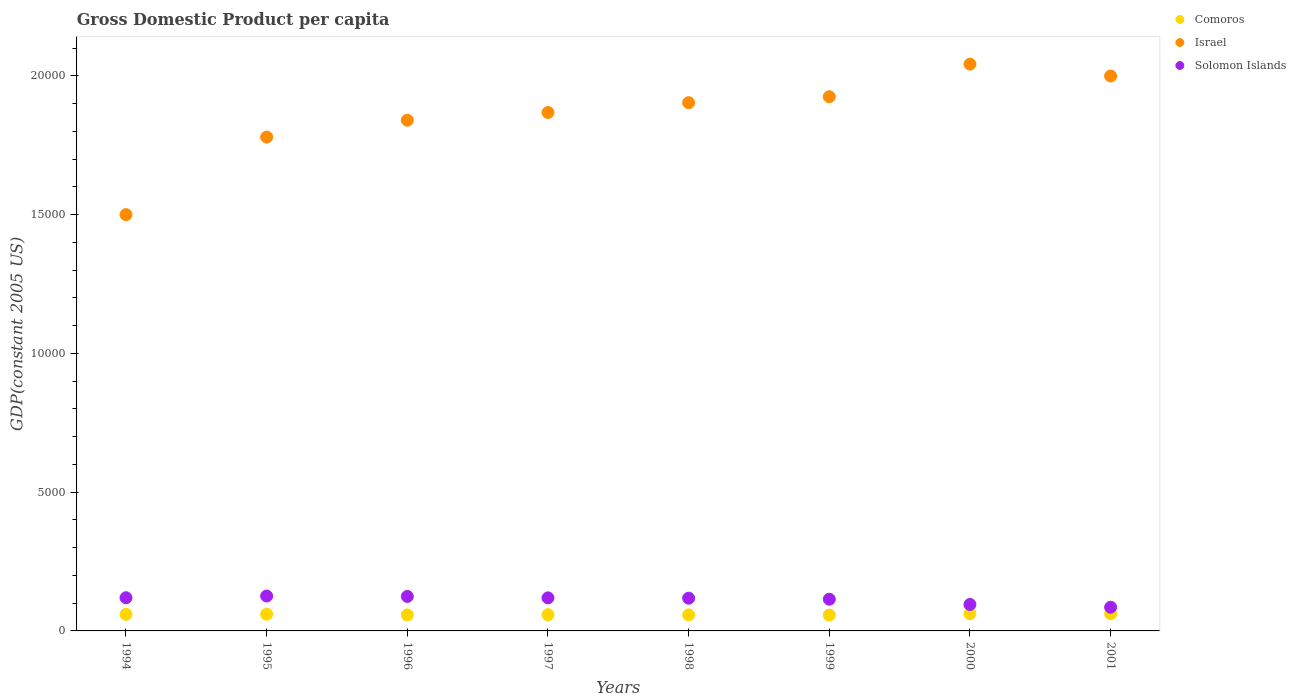How many different coloured dotlines are there?
Your answer should be compact. 3. Is the number of dotlines equal to the number of legend labels?
Ensure brevity in your answer.  Yes. What is the GDP per capita in Comoros in 1994?
Provide a short and direct response. 597.9. Across all years, what is the maximum GDP per capita in Solomon Islands?
Provide a short and direct response. 1257.72. Across all years, what is the minimum GDP per capita in Israel?
Keep it short and to the point. 1.50e+04. In which year was the GDP per capita in Israel maximum?
Give a very brief answer. 2000. What is the total GDP per capita in Israel in the graph?
Offer a very short reply. 1.49e+05. What is the difference between the GDP per capita in Comoros in 1995 and that in 2001?
Offer a very short reply. -16.24. What is the difference between the GDP per capita in Comoros in 1994 and the GDP per capita in Israel in 1999?
Provide a short and direct response. -1.87e+04. What is the average GDP per capita in Israel per year?
Your response must be concise. 1.86e+04. In the year 1999, what is the difference between the GDP per capita in Solomon Islands and GDP per capita in Comoros?
Your answer should be very brief. 568.47. In how many years, is the GDP per capita in Solomon Islands greater than 8000 US$?
Make the answer very short. 0. What is the ratio of the GDP per capita in Solomon Islands in 1994 to that in 1995?
Offer a terse response. 0.95. Is the GDP per capita in Solomon Islands in 1995 less than that in 1997?
Your answer should be very brief. No. What is the difference between the highest and the second highest GDP per capita in Solomon Islands?
Offer a terse response. 15.1. What is the difference between the highest and the lowest GDP per capita in Comoros?
Your answer should be very brief. 46.21. Is the sum of the GDP per capita in Comoros in 1999 and 2000 greater than the maximum GDP per capita in Israel across all years?
Your answer should be very brief. No. Is it the case that in every year, the sum of the GDP per capita in Comoros and GDP per capita in Israel  is greater than the GDP per capita in Solomon Islands?
Ensure brevity in your answer.  Yes. Does the GDP per capita in Israel monotonically increase over the years?
Give a very brief answer. No. Is the GDP per capita in Israel strictly less than the GDP per capita in Solomon Islands over the years?
Provide a succinct answer. No. What is the difference between two consecutive major ticks on the Y-axis?
Provide a short and direct response. 5000. Are the values on the major ticks of Y-axis written in scientific E-notation?
Ensure brevity in your answer.  No. Does the graph contain grids?
Offer a terse response. No. What is the title of the graph?
Make the answer very short. Gross Domestic Product per capita. What is the label or title of the X-axis?
Your response must be concise. Years. What is the label or title of the Y-axis?
Provide a succinct answer. GDP(constant 2005 US). What is the GDP(constant 2005 US) in Comoros in 1994?
Your response must be concise. 597.9. What is the GDP(constant 2005 US) of Israel in 1994?
Your answer should be compact. 1.50e+04. What is the GDP(constant 2005 US) in Solomon Islands in 1994?
Keep it short and to the point. 1195.38. What is the GDP(constant 2005 US) in Comoros in 1995?
Give a very brief answer. 602.35. What is the GDP(constant 2005 US) in Israel in 1995?
Provide a short and direct response. 1.78e+04. What is the GDP(constant 2005 US) of Solomon Islands in 1995?
Offer a very short reply. 1257.72. What is the GDP(constant 2005 US) of Comoros in 1996?
Your answer should be very brief. 578.41. What is the GDP(constant 2005 US) of Israel in 1996?
Keep it short and to the point. 1.84e+04. What is the GDP(constant 2005 US) of Solomon Islands in 1996?
Ensure brevity in your answer.  1242.62. What is the GDP(constant 2005 US) in Comoros in 1997?
Offer a very short reply. 585.63. What is the GDP(constant 2005 US) of Israel in 1997?
Your response must be concise. 1.87e+04. What is the GDP(constant 2005 US) in Solomon Islands in 1997?
Offer a terse response. 1191.13. What is the GDP(constant 2005 US) in Comoros in 1998?
Provide a short and direct response. 577.57. What is the GDP(constant 2005 US) in Israel in 1998?
Offer a very short reply. 1.90e+04. What is the GDP(constant 2005 US) in Solomon Islands in 1998?
Your response must be concise. 1179.38. What is the GDP(constant 2005 US) of Comoros in 1999?
Offer a very short reply. 573.54. What is the GDP(constant 2005 US) in Israel in 1999?
Give a very brief answer. 1.92e+04. What is the GDP(constant 2005 US) of Solomon Islands in 1999?
Your answer should be compact. 1142.01. What is the GDP(constant 2005 US) in Comoros in 2000?
Offer a terse response. 619.76. What is the GDP(constant 2005 US) of Israel in 2000?
Your response must be concise. 2.04e+04. What is the GDP(constant 2005 US) in Solomon Islands in 2000?
Ensure brevity in your answer.  952.92. What is the GDP(constant 2005 US) of Comoros in 2001?
Provide a succinct answer. 618.6. What is the GDP(constant 2005 US) in Israel in 2001?
Make the answer very short. 2.00e+04. What is the GDP(constant 2005 US) in Solomon Islands in 2001?
Your response must be concise. 853.7. Across all years, what is the maximum GDP(constant 2005 US) of Comoros?
Your response must be concise. 619.76. Across all years, what is the maximum GDP(constant 2005 US) of Israel?
Your response must be concise. 2.04e+04. Across all years, what is the maximum GDP(constant 2005 US) of Solomon Islands?
Offer a terse response. 1257.72. Across all years, what is the minimum GDP(constant 2005 US) in Comoros?
Provide a short and direct response. 573.54. Across all years, what is the minimum GDP(constant 2005 US) in Israel?
Provide a succinct answer. 1.50e+04. Across all years, what is the minimum GDP(constant 2005 US) in Solomon Islands?
Your answer should be very brief. 853.7. What is the total GDP(constant 2005 US) of Comoros in the graph?
Make the answer very short. 4753.75. What is the total GDP(constant 2005 US) of Israel in the graph?
Your response must be concise. 1.49e+05. What is the total GDP(constant 2005 US) in Solomon Islands in the graph?
Your answer should be compact. 9014.86. What is the difference between the GDP(constant 2005 US) in Comoros in 1994 and that in 1995?
Your answer should be very brief. -4.45. What is the difference between the GDP(constant 2005 US) in Israel in 1994 and that in 1995?
Ensure brevity in your answer.  -2793.13. What is the difference between the GDP(constant 2005 US) of Solomon Islands in 1994 and that in 1995?
Make the answer very short. -62.34. What is the difference between the GDP(constant 2005 US) of Comoros in 1994 and that in 1996?
Offer a terse response. 19.5. What is the difference between the GDP(constant 2005 US) in Israel in 1994 and that in 1996?
Your answer should be compact. -3400.92. What is the difference between the GDP(constant 2005 US) of Solomon Islands in 1994 and that in 1996?
Your answer should be very brief. -47.24. What is the difference between the GDP(constant 2005 US) in Comoros in 1994 and that in 1997?
Keep it short and to the point. 12.28. What is the difference between the GDP(constant 2005 US) in Israel in 1994 and that in 1997?
Ensure brevity in your answer.  -3679.51. What is the difference between the GDP(constant 2005 US) in Solomon Islands in 1994 and that in 1997?
Make the answer very short. 4.25. What is the difference between the GDP(constant 2005 US) of Comoros in 1994 and that in 1998?
Offer a very short reply. 20.34. What is the difference between the GDP(constant 2005 US) in Israel in 1994 and that in 1998?
Offer a terse response. -4033.44. What is the difference between the GDP(constant 2005 US) in Solomon Islands in 1994 and that in 1998?
Your answer should be compact. 16. What is the difference between the GDP(constant 2005 US) of Comoros in 1994 and that in 1999?
Ensure brevity in your answer.  24.36. What is the difference between the GDP(constant 2005 US) in Israel in 1994 and that in 1999?
Provide a succinct answer. -4248.29. What is the difference between the GDP(constant 2005 US) of Solomon Islands in 1994 and that in 1999?
Provide a short and direct response. 53.37. What is the difference between the GDP(constant 2005 US) of Comoros in 1994 and that in 2000?
Make the answer very short. -21.85. What is the difference between the GDP(constant 2005 US) in Israel in 1994 and that in 2000?
Provide a succinct answer. -5422.64. What is the difference between the GDP(constant 2005 US) of Solomon Islands in 1994 and that in 2000?
Make the answer very short. 242.46. What is the difference between the GDP(constant 2005 US) of Comoros in 1994 and that in 2001?
Ensure brevity in your answer.  -20.69. What is the difference between the GDP(constant 2005 US) of Israel in 1994 and that in 2001?
Provide a short and direct response. -4995.07. What is the difference between the GDP(constant 2005 US) in Solomon Islands in 1994 and that in 2001?
Keep it short and to the point. 341.68. What is the difference between the GDP(constant 2005 US) of Comoros in 1995 and that in 1996?
Your response must be concise. 23.95. What is the difference between the GDP(constant 2005 US) in Israel in 1995 and that in 1996?
Provide a succinct answer. -607.79. What is the difference between the GDP(constant 2005 US) of Solomon Islands in 1995 and that in 1996?
Keep it short and to the point. 15.1. What is the difference between the GDP(constant 2005 US) of Comoros in 1995 and that in 1997?
Make the answer very short. 16.73. What is the difference between the GDP(constant 2005 US) of Israel in 1995 and that in 1997?
Offer a very short reply. -886.38. What is the difference between the GDP(constant 2005 US) in Solomon Islands in 1995 and that in 1997?
Offer a very short reply. 66.59. What is the difference between the GDP(constant 2005 US) of Comoros in 1995 and that in 1998?
Offer a terse response. 24.79. What is the difference between the GDP(constant 2005 US) of Israel in 1995 and that in 1998?
Offer a very short reply. -1240.3. What is the difference between the GDP(constant 2005 US) in Solomon Islands in 1995 and that in 1998?
Offer a terse response. 78.34. What is the difference between the GDP(constant 2005 US) in Comoros in 1995 and that in 1999?
Your answer should be very brief. 28.81. What is the difference between the GDP(constant 2005 US) in Israel in 1995 and that in 1999?
Keep it short and to the point. -1455.16. What is the difference between the GDP(constant 2005 US) in Solomon Islands in 1995 and that in 1999?
Your answer should be compact. 115.71. What is the difference between the GDP(constant 2005 US) of Comoros in 1995 and that in 2000?
Provide a short and direct response. -17.4. What is the difference between the GDP(constant 2005 US) in Israel in 1995 and that in 2000?
Your response must be concise. -2629.51. What is the difference between the GDP(constant 2005 US) in Solomon Islands in 1995 and that in 2000?
Your answer should be compact. 304.81. What is the difference between the GDP(constant 2005 US) of Comoros in 1995 and that in 2001?
Your response must be concise. -16.24. What is the difference between the GDP(constant 2005 US) in Israel in 1995 and that in 2001?
Your response must be concise. -2201.94. What is the difference between the GDP(constant 2005 US) of Solomon Islands in 1995 and that in 2001?
Your answer should be compact. 404.02. What is the difference between the GDP(constant 2005 US) in Comoros in 1996 and that in 1997?
Your response must be concise. -7.22. What is the difference between the GDP(constant 2005 US) of Israel in 1996 and that in 1997?
Your answer should be compact. -278.59. What is the difference between the GDP(constant 2005 US) in Solomon Islands in 1996 and that in 1997?
Provide a succinct answer. 51.49. What is the difference between the GDP(constant 2005 US) of Comoros in 1996 and that in 1998?
Your response must be concise. 0.84. What is the difference between the GDP(constant 2005 US) of Israel in 1996 and that in 1998?
Your answer should be very brief. -632.51. What is the difference between the GDP(constant 2005 US) in Solomon Islands in 1996 and that in 1998?
Give a very brief answer. 63.24. What is the difference between the GDP(constant 2005 US) in Comoros in 1996 and that in 1999?
Your answer should be compact. 4.86. What is the difference between the GDP(constant 2005 US) of Israel in 1996 and that in 1999?
Your response must be concise. -847.37. What is the difference between the GDP(constant 2005 US) in Solomon Islands in 1996 and that in 1999?
Your answer should be very brief. 100.61. What is the difference between the GDP(constant 2005 US) of Comoros in 1996 and that in 2000?
Ensure brevity in your answer.  -41.35. What is the difference between the GDP(constant 2005 US) in Israel in 1996 and that in 2000?
Give a very brief answer. -2021.72. What is the difference between the GDP(constant 2005 US) in Solomon Islands in 1996 and that in 2000?
Your answer should be compact. 289.7. What is the difference between the GDP(constant 2005 US) of Comoros in 1996 and that in 2001?
Make the answer very short. -40.19. What is the difference between the GDP(constant 2005 US) in Israel in 1996 and that in 2001?
Provide a succinct answer. -1594.15. What is the difference between the GDP(constant 2005 US) in Solomon Islands in 1996 and that in 2001?
Offer a terse response. 388.92. What is the difference between the GDP(constant 2005 US) of Comoros in 1997 and that in 1998?
Provide a succinct answer. 8.06. What is the difference between the GDP(constant 2005 US) in Israel in 1997 and that in 1998?
Provide a succinct answer. -353.93. What is the difference between the GDP(constant 2005 US) of Solomon Islands in 1997 and that in 1998?
Your response must be concise. 11.76. What is the difference between the GDP(constant 2005 US) in Comoros in 1997 and that in 1999?
Make the answer very short. 12.08. What is the difference between the GDP(constant 2005 US) of Israel in 1997 and that in 1999?
Make the answer very short. -568.78. What is the difference between the GDP(constant 2005 US) in Solomon Islands in 1997 and that in 1999?
Provide a short and direct response. 49.12. What is the difference between the GDP(constant 2005 US) of Comoros in 1997 and that in 2000?
Ensure brevity in your answer.  -34.13. What is the difference between the GDP(constant 2005 US) in Israel in 1997 and that in 2000?
Keep it short and to the point. -1743.13. What is the difference between the GDP(constant 2005 US) in Solomon Islands in 1997 and that in 2000?
Keep it short and to the point. 238.22. What is the difference between the GDP(constant 2005 US) in Comoros in 1997 and that in 2001?
Ensure brevity in your answer.  -32.97. What is the difference between the GDP(constant 2005 US) in Israel in 1997 and that in 2001?
Your answer should be compact. -1315.56. What is the difference between the GDP(constant 2005 US) in Solomon Islands in 1997 and that in 2001?
Provide a succinct answer. 337.43. What is the difference between the GDP(constant 2005 US) of Comoros in 1998 and that in 1999?
Provide a short and direct response. 4.02. What is the difference between the GDP(constant 2005 US) of Israel in 1998 and that in 1999?
Keep it short and to the point. -214.85. What is the difference between the GDP(constant 2005 US) of Solomon Islands in 1998 and that in 1999?
Give a very brief answer. 37.36. What is the difference between the GDP(constant 2005 US) of Comoros in 1998 and that in 2000?
Ensure brevity in your answer.  -42.19. What is the difference between the GDP(constant 2005 US) in Israel in 1998 and that in 2000?
Make the answer very short. -1389.2. What is the difference between the GDP(constant 2005 US) in Solomon Islands in 1998 and that in 2000?
Your answer should be compact. 226.46. What is the difference between the GDP(constant 2005 US) of Comoros in 1998 and that in 2001?
Offer a very short reply. -41.03. What is the difference between the GDP(constant 2005 US) of Israel in 1998 and that in 2001?
Offer a terse response. -961.64. What is the difference between the GDP(constant 2005 US) of Solomon Islands in 1998 and that in 2001?
Ensure brevity in your answer.  325.68. What is the difference between the GDP(constant 2005 US) in Comoros in 1999 and that in 2000?
Ensure brevity in your answer.  -46.21. What is the difference between the GDP(constant 2005 US) of Israel in 1999 and that in 2000?
Offer a very short reply. -1174.35. What is the difference between the GDP(constant 2005 US) in Solomon Islands in 1999 and that in 2000?
Offer a terse response. 189.1. What is the difference between the GDP(constant 2005 US) of Comoros in 1999 and that in 2001?
Ensure brevity in your answer.  -45.05. What is the difference between the GDP(constant 2005 US) of Israel in 1999 and that in 2001?
Offer a terse response. -746.78. What is the difference between the GDP(constant 2005 US) of Solomon Islands in 1999 and that in 2001?
Offer a very short reply. 288.31. What is the difference between the GDP(constant 2005 US) in Comoros in 2000 and that in 2001?
Keep it short and to the point. 1.16. What is the difference between the GDP(constant 2005 US) of Israel in 2000 and that in 2001?
Provide a short and direct response. 427.56. What is the difference between the GDP(constant 2005 US) in Solomon Islands in 2000 and that in 2001?
Offer a terse response. 99.22. What is the difference between the GDP(constant 2005 US) of Comoros in 1994 and the GDP(constant 2005 US) of Israel in 1995?
Your answer should be very brief. -1.72e+04. What is the difference between the GDP(constant 2005 US) in Comoros in 1994 and the GDP(constant 2005 US) in Solomon Islands in 1995?
Give a very brief answer. -659.82. What is the difference between the GDP(constant 2005 US) in Israel in 1994 and the GDP(constant 2005 US) in Solomon Islands in 1995?
Offer a very short reply. 1.37e+04. What is the difference between the GDP(constant 2005 US) of Comoros in 1994 and the GDP(constant 2005 US) of Israel in 1996?
Give a very brief answer. -1.78e+04. What is the difference between the GDP(constant 2005 US) of Comoros in 1994 and the GDP(constant 2005 US) of Solomon Islands in 1996?
Give a very brief answer. -644.72. What is the difference between the GDP(constant 2005 US) of Israel in 1994 and the GDP(constant 2005 US) of Solomon Islands in 1996?
Your answer should be very brief. 1.38e+04. What is the difference between the GDP(constant 2005 US) of Comoros in 1994 and the GDP(constant 2005 US) of Israel in 1997?
Your answer should be compact. -1.81e+04. What is the difference between the GDP(constant 2005 US) of Comoros in 1994 and the GDP(constant 2005 US) of Solomon Islands in 1997?
Offer a very short reply. -593.23. What is the difference between the GDP(constant 2005 US) in Israel in 1994 and the GDP(constant 2005 US) in Solomon Islands in 1997?
Keep it short and to the point. 1.38e+04. What is the difference between the GDP(constant 2005 US) of Comoros in 1994 and the GDP(constant 2005 US) of Israel in 1998?
Provide a short and direct response. -1.84e+04. What is the difference between the GDP(constant 2005 US) in Comoros in 1994 and the GDP(constant 2005 US) in Solomon Islands in 1998?
Offer a very short reply. -581.47. What is the difference between the GDP(constant 2005 US) in Israel in 1994 and the GDP(constant 2005 US) in Solomon Islands in 1998?
Ensure brevity in your answer.  1.38e+04. What is the difference between the GDP(constant 2005 US) in Comoros in 1994 and the GDP(constant 2005 US) in Israel in 1999?
Ensure brevity in your answer.  -1.87e+04. What is the difference between the GDP(constant 2005 US) of Comoros in 1994 and the GDP(constant 2005 US) of Solomon Islands in 1999?
Offer a terse response. -544.11. What is the difference between the GDP(constant 2005 US) of Israel in 1994 and the GDP(constant 2005 US) of Solomon Islands in 1999?
Your answer should be compact. 1.39e+04. What is the difference between the GDP(constant 2005 US) of Comoros in 1994 and the GDP(constant 2005 US) of Israel in 2000?
Your response must be concise. -1.98e+04. What is the difference between the GDP(constant 2005 US) of Comoros in 1994 and the GDP(constant 2005 US) of Solomon Islands in 2000?
Provide a short and direct response. -355.01. What is the difference between the GDP(constant 2005 US) in Israel in 1994 and the GDP(constant 2005 US) in Solomon Islands in 2000?
Offer a very short reply. 1.40e+04. What is the difference between the GDP(constant 2005 US) of Comoros in 1994 and the GDP(constant 2005 US) of Israel in 2001?
Keep it short and to the point. -1.94e+04. What is the difference between the GDP(constant 2005 US) in Comoros in 1994 and the GDP(constant 2005 US) in Solomon Islands in 2001?
Provide a short and direct response. -255.8. What is the difference between the GDP(constant 2005 US) in Israel in 1994 and the GDP(constant 2005 US) in Solomon Islands in 2001?
Your answer should be compact. 1.41e+04. What is the difference between the GDP(constant 2005 US) in Comoros in 1995 and the GDP(constant 2005 US) in Israel in 1996?
Offer a very short reply. -1.78e+04. What is the difference between the GDP(constant 2005 US) in Comoros in 1995 and the GDP(constant 2005 US) in Solomon Islands in 1996?
Give a very brief answer. -640.27. What is the difference between the GDP(constant 2005 US) of Israel in 1995 and the GDP(constant 2005 US) of Solomon Islands in 1996?
Keep it short and to the point. 1.66e+04. What is the difference between the GDP(constant 2005 US) in Comoros in 1995 and the GDP(constant 2005 US) in Israel in 1997?
Your answer should be compact. -1.81e+04. What is the difference between the GDP(constant 2005 US) in Comoros in 1995 and the GDP(constant 2005 US) in Solomon Islands in 1997?
Make the answer very short. -588.78. What is the difference between the GDP(constant 2005 US) in Israel in 1995 and the GDP(constant 2005 US) in Solomon Islands in 1997?
Give a very brief answer. 1.66e+04. What is the difference between the GDP(constant 2005 US) in Comoros in 1995 and the GDP(constant 2005 US) in Israel in 1998?
Offer a terse response. -1.84e+04. What is the difference between the GDP(constant 2005 US) in Comoros in 1995 and the GDP(constant 2005 US) in Solomon Islands in 1998?
Make the answer very short. -577.02. What is the difference between the GDP(constant 2005 US) of Israel in 1995 and the GDP(constant 2005 US) of Solomon Islands in 1998?
Provide a short and direct response. 1.66e+04. What is the difference between the GDP(constant 2005 US) of Comoros in 1995 and the GDP(constant 2005 US) of Israel in 1999?
Offer a very short reply. -1.86e+04. What is the difference between the GDP(constant 2005 US) in Comoros in 1995 and the GDP(constant 2005 US) in Solomon Islands in 1999?
Offer a terse response. -539.66. What is the difference between the GDP(constant 2005 US) in Israel in 1995 and the GDP(constant 2005 US) in Solomon Islands in 1999?
Offer a very short reply. 1.67e+04. What is the difference between the GDP(constant 2005 US) in Comoros in 1995 and the GDP(constant 2005 US) in Israel in 2000?
Provide a short and direct response. -1.98e+04. What is the difference between the GDP(constant 2005 US) in Comoros in 1995 and the GDP(constant 2005 US) in Solomon Islands in 2000?
Offer a terse response. -350.56. What is the difference between the GDP(constant 2005 US) in Israel in 1995 and the GDP(constant 2005 US) in Solomon Islands in 2000?
Give a very brief answer. 1.68e+04. What is the difference between the GDP(constant 2005 US) of Comoros in 1995 and the GDP(constant 2005 US) of Israel in 2001?
Provide a succinct answer. -1.94e+04. What is the difference between the GDP(constant 2005 US) of Comoros in 1995 and the GDP(constant 2005 US) of Solomon Islands in 2001?
Make the answer very short. -251.35. What is the difference between the GDP(constant 2005 US) of Israel in 1995 and the GDP(constant 2005 US) of Solomon Islands in 2001?
Offer a terse response. 1.69e+04. What is the difference between the GDP(constant 2005 US) of Comoros in 1996 and the GDP(constant 2005 US) of Israel in 1997?
Give a very brief answer. -1.81e+04. What is the difference between the GDP(constant 2005 US) in Comoros in 1996 and the GDP(constant 2005 US) in Solomon Islands in 1997?
Offer a very short reply. -612.73. What is the difference between the GDP(constant 2005 US) of Israel in 1996 and the GDP(constant 2005 US) of Solomon Islands in 1997?
Your answer should be compact. 1.72e+04. What is the difference between the GDP(constant 2005 US) in Comoros in 1996 and the GDP(constant 2005 US) in Israel in 1998?
Your answer should be compact. -1.85e+04. What is the difference between the GDP(constant 2005 US) in Comoros in 1996 and the GDP(constant 2005 US) in Solomon Islands in 1998?
Your response must be concise. -600.97. What is the difference between the GDP(constant 2005 US) of Israel in 1996 and the GDP(constant 2005 US) of Solomon Islands in 1998?
Keep it short and to the point. 1.72e+04. What is the difference between the GDP(constant 2005 US) in Comoros in 1996 and the GDP(constant 2005 US) in Israel in 1999?
Give a very brief answer. -1.87e+04. What is the difference between the GDP(constant 2005 US) in Comoros in 1996 and the GDP(constant 2005 US) in Solomon Islands in 1999?
Ensure brevity in your answer.  -563.61. What is the difference between the GDP(constant 2005 US) of Israel in 1996 and the GDP(constant 2005 US) of Solomon Islands in 1999?
Ensure brevity in your answer.  1.73e+04. What is the difference between the GDP(constant 2005 US) in Comoros in 1996 and the GDP(constant 2005 US) in Israel in 2000?
Your response must be concise. -1.98e+04. What is the difference between the GDP(constant 2005 US) in Comoros in 1996 and the GDP(constant 2005 US) in Solomon Islands in 2000?
Give a very brief answer. -374.51. What is the difference between the GDP(constant 2005 US) in Israel in 1996 and the GDP(constant 2005 US) in Solomon Islands in 2000?
Give a very brief answer. 1.74e+04. What is the difference between the GDP(constant 2005 US) of Comoros in 1996 and the GDP(constant 2005 US) of Israel in 2001?
Ensure brevity in your answer.  -1.94e+04. What is the difference between the GDP(constant 2005 US) in Comoros in 1996 and the GDP(constant 2005 US) in Solomon Islands in 2001?
Offer a very short reply. -275.29. What is the difference between the GDP(constant 2005 US) of Israel in 1996 and the GDP(constant 2005 US) of Solomon Islands in 2001?
Provide a short and direct response. 1.75e+04. What is the difference between the GDP(constant 2005 US) in Comoros in 1997 and the GDP(constant 2005 US) in Israel in 1998?
Provide a succinct answer. -1.84e+04. What is the difference between the GDP(constant 2005 US) of Comoros in 1997 and the GDP(constant 2005 US) of Solomon Islands in 1998?
Provide a succinct answer. -593.75. What is the difference between the GDP(constant 2005 US) of Israel in 1997 and the GDP(constant 2005 US) of Solomon Islands in 1998?
Keep it short and to the point. 1.75e+04. What is the difference between the GDP(constant 2005 US) of Comoros in 1997 and the GDP(constant 2005 US) of Israel in 1999?
Keep it short and to the point. -1.87e+04. What is the difference between the GDP(constant 2005 US) in Comoros in 1997 and the GDP(constant 2005 US) in Solomon Islands in 1999?
Your answer should be compact. -556.39. What is the difference between the GDP(constant 2005 US) in Israel in 1997 and the GDP(constant 2005 US) in Solomon Islands in 1999?
Ensure brevity in your answer.  1.75e+04. What is the difference between the GDP(constant 2005 US) of Comoros in 1997 and the GDP(constant 2005 US) of Israel in 2000?
Ensure brevity in your answer.  -1.98e+04. What is the difference between the GDP(constant 2005 US) of Comoros in 1997 and the GDP(constant 2005 US) of Solomon Islands in 2000?
Your answer should be compact. -367.29. What is the difference between the GDP(constant 2005 US) of Israel in 1997 and the GDP(constant 2005 US) of Solomon Islands in 2000?
Offer a terse response. 1.77e+04. What is the difference between the GDP(constant 2005 US) of Comoros in 1997 and the GDP(constant 2005 US) of Israel in 2001?
Provide a succinct answer. -1.94e+04. What is the difference between the GDP(constant 2005 US) in Comoros in 1997 and the GDP(constant 2005 US) in Solomon Islands in 2001?
Your response must be concise. -268.07. What is the difference between the GDP(constant 2005 US) in Israel in 1997 and the GDP(constant 2005 US) in Solomon Islands in 2001?
Keep it short and to the point. 1.78e+04. What is the difference between the GDP(constant 2005 US) in Comoros in 1998 and the GDP(constant 2005 US) in Israel in 1999?
Offer a terse response. -1.87e+04. What is the difference between the GDP(constant 2005 US) of Comoros in 1998 and the GDP(constant 2005 US) of Solomon Islands in 1999?
Your answer should be very brief. -564.44. What is the difference between the GDP(constant 2005 US) of Israel in 1998 and the GDP(constant 2005 US) of Solomon Islands in 1999?
Provide a succinct answer. 1.79e+04. What is the difference between the GDP(constant 2005 US) of Comoros in 1998 and the GDP(constant 2005 US) of Israel in 2000?
Offer a very short reply. -1.98e+04. What is the difference between the GDP(constant 2005 US) in Comoros in 1998 and the GDP(constant 2005 US) in Solomon Islands in 2000?
Ensure brevity in your answer.  -375.35. What is the difference between the GDP(constant 2005 US) in Israel in 1998 and the GDP(constant 2005 US) in Solomon Islands in 2000?
Keep it short and to the point. 1.81e+04. What is the difference between the GDP(constant 2005 US) in Comoros in 1998 and the GDP(constant 2005 US) in Israel in 2001?
Ensure brevity in your answer.  -1.94e+04. What is the difference between the GDP(constant 2005 US) of Comoros in 1998 and the GDP(constant 2005 US) of Solomon Islands in 2001?
Your response must be concise. -276.13. What is the difference between the GDP(constant 2005 US) of Israel in 1998 and the GDP(constant 2005 US) of Solomon Islands in 2001?
Ensure brevity in your answer.  1.82e+04. What is the difference between the GDP(constant 2005 US) in Comoros in 1999 and the GDP(constant 2005 US) in Israel in 2000?
Provide a succinct answer. -1.98e+04. What is the difference between the GDP(constant 2005 US) of Comoros in 1999 and the GDP(constant 2005 US) of Solomon Islands in 2000?
Give a very brief answer. -379.37. What is the difference between the GDP(constant 2005 US) of Israel in 1999 and the GDP(constant 2005 US) of Solomon Islands in 2000?
Keep it short and to the point. 1.83e+04. What is the difference between the GDP(constant 2005 US) in Comoros in 1999 and the GDP(constant 2005 US) in Israel in 2001?
Make the answer very short. -1.94e+04. What is the difference between the GDP(constant 2005 US) of Comoros in 1999 and the GDP(constant 2005 US) of Solomon Islands in 2001?
Your answer should be very brief. -280.16. What is the difference between the GDP(constant 2005 US) of Israel in 1999 and the GDP(constant 2005 US) of Solomon Islands in 2001?
Make the answer very short. 1.84e+04. What is the difference between the GDP(constant 2005 US) of Comoros in 2000 and the GDP(constant 2005 US) of Israel in 2001?
Your answer should be compact. -1.94e+04. What is the difference between the GDP(constant 2005 US) in Comoros in 2000 and the GDP(constant 2005 US) in Solomon Islands in 2001?
Give a very brief answer. -233.94. What is the difference between the GDP(constant 2005 US) in Israel in 2000 and the GDP(constant 2005 US) in Solomon Islands in 2001?
Give a very brief answer. 1.96e+04. What is the average GDP(constant 2005 US) of Comoros per year?
Ensure brevity in your answer.  594.22. What is the average GDP(constant 2005 US) of Israel per year?
Your answer should be compact. 1.86e+04. What is the average GDP(constant 2005 US) in Solomon Islands per year?
Your answer should be compact. 1126.86. In the year 1994, what is the difference between the GDP(constant 2005 US) of Comoros and GDP(constant 2005 US) of Israel?
Offer a very short reply. -1.44e+04. In the year 1994, what is the difference between the GDP(constant 2005 US) of Comoros and GDP(constant 2005 US) of Solomon Islands?
Your response must be concise. -597.48. In the year 1994, what is the difference between the GDP(constant 2005 US) of Israel and GDP(constant 2005 US) of Solomon Islands?
Offer a terse response. 1.38e+04. In the year 1995, what is the difference between the GDP(constant 2005 US) of Comoros and GDP(constant 2005 US) of Israel?
Your response must be concise. -1.72e+04. In the year 1995, what is the difference between the GDP(constant 2005 US) in Comoros and GDP(constant 2005 US) in Solomon Islands?
Provide a succinct answer. -655.37. In the year 1995, what is the difference between the GDP(constant 2005 US) in Israel and GDP(constant 2005 US) in Solomon Islands?
Your answer should be compact. 1.65e+04. In the year 1996, what is the difference between the GDP(constant 2005 US) in Comoros and GDP(constant 2005 US) in Israel?
Your response must be concise. -1.78e+04. In the year 1996, what is the difference between the GDP(constant 2005 US) of Comoros and GDP(constant 2005 US) of Solomon Islands?
Ensure brevity in your answer.  -664.21. In the year 1996, what is the difference between the GDP(constant 2005 US) of Israel and GDP(constant 2005 US) of Solomon Islands?
Offer a very short reply. 1.72e+04. In the year 1997, what is the difference between the GDP(constant 2005 US) in Comoros and GDP(constant 2005 US) in Israel?
Provide a succinct answer. -1.81e+04. In the year 1997, what is the difference between the GDP(constant 2005 US) in Comoros and GDP(constant 2005 US) in Solomon Islands?
Provide a succinct answer. -605.51. In the year 1997, what is the difference between the GDP(constant 2005 US) of Israel and GDP(constant 2005 US) of Solomon Islands?
Offer a terse response. 1.75e+04. In the year 1998, what is the difference between the GDP(constant 2005 US) in Comoros and GDP(constant 2005 US) in Israel?
Offer a terse response. -1.85e+04. In the year 1998, what is the difference between the GDP(constant 2005 US) of Comoros and GDP(constant 2005 US) of Solomon Islands?
Your response must be concise. -601.81. In the year 1998, what is the difference between the GDP(constant 2005 US) in Israel and GDP(constant 2005 US) in Solomon Islands?
Provide a short and direct response. 1.79e+04. In the year 1999, what is the difference between the GDP(constant 2005 US) in Comoros and GDP(constant 2005 US) in Israel?
Your response must be concise. -1.87e+04. In the year 1999, what is the difference between the GDP(constant 2005 US) in Comoros and GDP(constant 2005 US) in Solomon Islands?
Give a very brief answer. -568.47. In the year 1999, what is the difference between the GDP(constant 2005 US) of Israel and GDP(constant 2005 US) of Solomon Islands?
Make the answer very short. 1.81e+04. In the year 2000, what is the difference between the GDP(constant 2005 US) of Comoros and GDP(constant 2005 US) of Israel?
Provide a short and direct response. -1.98e+04. In the year 2000, what is the difference between the GDP(constant 2005 US) of Comoros and GDP(constant 2005 US) of Solomon Islands?
Provide a succinct answer. -333.16. In the year 2000, what is the difference between the GDP(constant 2005 US) of Israel and GDP(constant 2005 US) of Solomon Islands?
Offer a very short reply. 1.95e+04. In the year 2001, what is the difference between the GDP(constant 2005 US) in Comoros and GDP(constant 2005 US) in Israel?
Give a very brief answer. -1.94e+04. In the year 2001, what is the difference between the GDP(constant 2005 US) of Comoros and GDP(constant 2005 US) of Solomon Islands?
Make the answer very short. -235.1. In the year 2001, what is the difference between the GDP(constant 2005 US) in Israel and GDP(constant 2005 US) in Solomon Islands?
Your response must be concise. 1.91e+04. What is the ratio of the GDP(constant 2005 US) in Comoros in 1994 to that in 1995?
Offer a terse response. 0.99. What is the ratio of the GDP(constant 2005 US) in Israel in 1994 to that in 1995?
Your answer should be very brief. 0.84. What is the ratio of the GDP(constant 2005 US) of Solomon Islands in 1994 to that in 1995?
Give a very brief answer. 0.95. What is the ratio of the GDP(constant 2005 US) of Comoros in 1994 to that in 1996?
Provide a short and direct response. 1.03. What is the ratio of the GDP(constant 2005 US) in Israel in 1994 to that in 1996?
Give a very brief answer. 0.82. What is the ratio of the GDP(constant 2005 US) of Comoros in 1994 to that in 1997?
Make the answer very short. 1.02. What is the ratio of the GDP(constant 2005 US) in Israel in 1994 to that in 1997?
Your answer should be compact. 0.8. What is the ratio of the GDP(constant 2005 US) of Solomon Islands in 1994 to that in 1997?
Make the answer very short. 1. What is the ratio of the GDP(constant 2005 US) of Comoros in 1994 to that in 1998?
Offer a very short reply. 1.04. What is the ratio of the GDP(constant 2005 US) of Israel in 1994 to that in 1998?
Your answer should be very brief. 0.79. What is the ratio of the GDP(constant 2005 US) in Solomon Islands in 1994 to that in 1998?
Make the answer very short. 1.01. What is the ratio of the GDP(constant 2005 US) of Comoros in 1994 to that in 1999?
Offer a very short reply. 1.04. What is the ratio of the GDP(constant 2005 US) in Israel in 1994 to that in 1999?
Keep it short and to the point. 0.78. What is the ratio of the GDP(constant 2005 US) of Solomon Islands in 1994 to that in 1999?
Make the answer very short. 1.05. What is the ratio of the GDP(constant 2005 US) of Comoros in 1994 to that in 2000?
Your response must be concise. 0.96. What is the ratio of the GDP(constant 2005 US) in Israel in 1994 to that in 2000?
Give a very brief answer. 0.73. What is the ratio of the GDP(constant 2005 US) in Solomon Islands in 1994 to that in 2000?
Your response must be concise. 1.25. What is the ratio of the GDP(constant 2005 US) of Comoros in 1994 to that in 2001?
Offer a very short reply. 0.97. What is the ratio of the GDP(constant 2005 US) of Israel in 1994 to that in 2001?
Make the answer very short. 0.75. What is the ratio of the GDP(constant 2005 US) in Solomon Islands in 1994 to that in 2001?
Offer a very short reply. 1.4. What is the ratio of the GDP(constant 2005 US) in Comoros in 1995 to that in 1996?
Your response must be concise. 1.04. What is the ratio of the GDP(constant 2005 US) of Solomon Islands in 1995 to that in 1996?
Provide a succinct answer. 1.01. What is the ratio of the GDP(constant 2005 US) in Comoros in 1995 to that in 1997?
Your response must be concise. 1.03. What is the ratio of the GDP(constant 2005 US) of Israel in 1995 to that in 1997?
Give a very brief answer. 0.95. What is the ratio of the GDP(constant 2005 US) of Solomon Islands in 1995 to that in 1997?
Provide a short and direct response. 1.06. What is the ratio of the GDP(constant 2005 US) in Comoros in 1995 to that in 1998?
Provide a short and direct response. 1.04. What is the ratio of the GDP(constant 2005 US) in Israel in 1995 to that in 1998?
Your answer should be compact. 0.93. What is the ratio of the GDP(constant 2005 US) of Solomon Islands in 1995 to that in 1998?
Ensure brevity in your answer.  1.07. What is the ratio of the GDP(constant 2005 US) of Comoros in 1995 to that in 1999?
Offer a terse response. 1.05. What is the ratio of the GDP(constant 2005 US) of Israel in 1995 to that in 1999?
Your answer should be compact. 0.92. What is the ratio of the GDP(constant 2005 US) in Solomon Islands in 1995 to that in 1999?
Make the answer very short. 1.1. What is the ratio of the GDP(constant 2005 US) of Comoros in 1995 to that in 2000?
Offer a terse response. 0.97. What is the ratio of the GDP(constant 2005 US) in Israel in 1995 to that in 2000?
Your response must be concise. 0.87. What is the ratio of the GDP(constant 2005 US) of Solomon Islands in 1995 to that in 2000?
Your answer should be very brief. 1.32. What is the ratio of the GDP(constant 2005 US) in Comoros in 1995 to that in 2001?
Your answer should be compact. 0.97. What is the ratio of the GDP(constant 2005 US) of Israel in 1995 to that in 2001?
Offer a very short reply. 0.89. What is the ratio of the GDP(constant 2005 US) of Solomon Islands in 1995 to that in 2001?
Offer a terse response. 1.47. What is the ratio of the GDP(constant 2005 US) of Comoros in 1996 to that in 1997?
Keep it short and to the point. 0.99. What is the ratio of the GDP(constant 2005 US) in Israel in 1996 to that in 1997?
Make the answer very short. 0.99. What is the ratio of the GDP(constant 2005 US) of Solomon Islands in 1996 to that in 1997?
Provide a succinct answer. 1.04. What is the ratio of the GDP(constant 2005 US) of Comoros in 1996 to that in 1998?
Provide a short and direct response. 1. What is the ratio of the GDP(constant 2005 US) of Israel in 1996 to that in 1998?
Provide a succinct answer. 0.97. What is the ratio of the GDP(constant 2005 US) of Solomon Islands in 1996 to that in 1998?
Give a very brief answer. 1.05. What is the ratio of the GDP(constant 2005 US) in Comoros in 1996 to that in 1999?
Offer a very short reply. 1.01. What is the ratio of the GDP(constant 2005 US) in Israel in 1996 to that in 1999?
Keep it short and to the point. 0.96. What is the ratio of the GDP(constant 2005 US) in Solomon Islands in 1996 to that in 1999?
Offer a terse response. 1.09. What is the ratio of the GDP(constant 2005 US) in Comoros in 1996 to that in 2000?
Provide a succinct answer. 0.93. What is the ratio of the GDP(constant 2005 US) in Israel in 1996 to that in 2000?
Keep it short and to the point. 0.9. What is the ratio of the GDP(constant 2005 US) in Solomon Islands in 1996 to that in 2000?
Keep it short and to the point. 1.3. What is the ratio of the GDP(constant 2005 US) of Comoros in 1996 to that in 2001?
Keep it short and to the point. 0.94. What is the ratio of the GDP(constant 2005 US) of Israel in 1996 to that in 2001?
Provide a short and direct response. 0.92. What is the ratio of the GDP(constant 2005 US) in Solomon Islands in 1996 to that in 2001?
Your response must be concise. 1.46. What is the ratio of the GDP(constant 2005 US) in Comoros in 1997 to that in 1998?
Provide a succinct answer. 1.01. What is the ratio of the GDP(constant 2005 US) in Israel in 1997 to that in 1998?
Make the answer very short. 0.98. What is the ratio of the GDP(constant 2005 US) in Comoros in 1997 to that in 1999?
Ensure brevity in your answer.  1.02. What is the ratio of the GDP(constant 2005 US) of Israel in 1997 to that in 1999?
Your answer should be compact. 0.97. What is the ratio of the GDP(constant 2005 US) of Solomon Islands in 1997 to that in 1999?
Your answer should be compact. 1.04. What is the ratio of the GDP(constant 2005 US) of Comoros in 1997 to that in 2000?
Make the answer very short. 0.94. What is the ratio of the GDP(constant 2005 US) of Israel in 1997 to that in 2000?
Provide a succinct answer. 0.91. What is the ratio of the GDP(constant 2005 US) in Comoros in 1997 to that in 2001?
Keep it short and to the point. 0.95. What is the ratio of the GDP(constant 2005 US) in Israel in 1997 to that in 2001?
Keep it short and to the point. 0.93. What is the ratio of the GDP(constant 2005 US) of Solomon Islands in 1997 to that in 2001?
Provide a succinct answer. 1.4. What is the ratio of the GDP(constant 2005 US) in Israel in 1998 to that in 1999?
Ensure brevity in your answer.  0.99. What is the ratio of the GDP(constant 2005 US) of Solomon Islands in 1998 to that in 1999?
Your answer should be compact. 1.03. What is the ratio of the GDP(constant 2005 US) in Comoros in 1998 to that in 2000?
Your response must be concise. 0.93. What is the ratio of the GDP(constant 2005 US) of Israel in 1998 to that in 2000?
Ensure brevity in your answer.  0.93. What is the ratio of the GDP(constant 2005 US) in Solomon Islands in 1998 to that in 2000?
Ensure brevity in your answer.  1.24. What is the ratio of the GDP(constant 2005 US) of Comoros in 1998 to that in 2001?
Provide a succinct answer. 0.93. What is the ratio of the GDP(constant 2005 US) in Israel in 1998 to that in 2001?
Provide a short and direct response. 0.95. What is the ratio of the GDP(constant 2005 US) in Solomon Islands in 1998 to that in 2001?
Provide a succinct answer. 1.38. What is the ratio of the GDP(constant 2005 US) in Comoros in 1999 to that in 2000?
Provide a succinct answer. 0.93. What is the ratio of the GDP(constant 2005 US) of Israel in 1999 to that in 2000?
Ensure brevity in your answer.  0.94. What is the ratio of the GDP(constant 2005 US) of Solomon Islands in 1999 to that in 2000?
Provide a short and direct response. 1.2. What is the ratio of the GDP(constant 2005 US) of Comoros in 1999 to that in 2001?
Keep it short and to the point. 0.93. What is the ratio of the GDP(constant 2005 US) of Israel in 1999 to that in 2001?
Provide a succinct answer. 0.96. What is the ratio of the GDP(constant 2005 US) of Solomon Islands in 1999 to that in 2001?
Ensure brevity in your answer.  1.34. What is the ratio of the GDP(constant 2005 US) in Comoros in 2000 to that in 2001?
Your response must be concise. 1. What is the ratio of the GDP(constant 2005 US) of Israel in 2000 to that in 2001?
Offer a very short reply. 1.02. What is the ratio of the GDP(constant 2005 US) of Solomon Islands in 2000 to that in 2001?
Your answer should be very brief. 1.12. What is the difference between the highest and the second highest GDP(constant 2005 US) in Comoros?
Ensure brevity in your answer.  1.16. What is the difference between the highest and the second highest GDP(constant 2005 US) of Israel?
Make the answer very short. 427.56. What is the difference between the highest and the second highest GDP(constant 2005 US) in Solomon Islands?
Your response must be concise. 15.1. What is the difference between the highest and the lowest GDP(constant 2005 US) of Comoros?
Provide a short and direct response. 46.21. What is the difference between the highest and the lowest GDP(constant 2005 US) in Israel?
Your response must be concise. 5422.64. What is the difference between the highest and the lowest GDP(constant 2005 US) in Solomon Islands?
Your answer should be very brief. 404.02. 